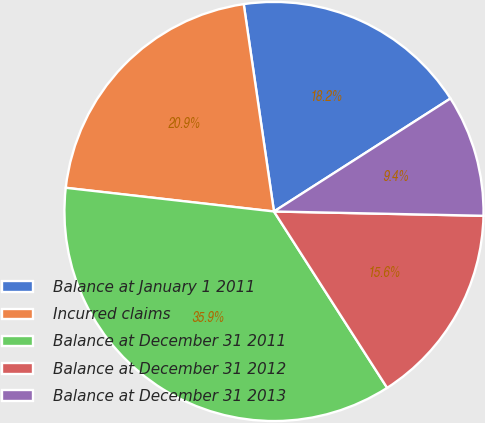Convert chart. <chart><loc_0><loc_0><loc_500><loc_500><pie_chart><fcel>Balance at January 1 2011<fcel>Incurred claims<fcel>Balance at December 31 2011<fcel>Balance at December 31 2012<fcel>Balance at December 31 2013<nl><fcel>18.24%<fcel>20.89%<fcel>35.88%<fcel>15.59%<fcel>9.39%<nl></chart> 